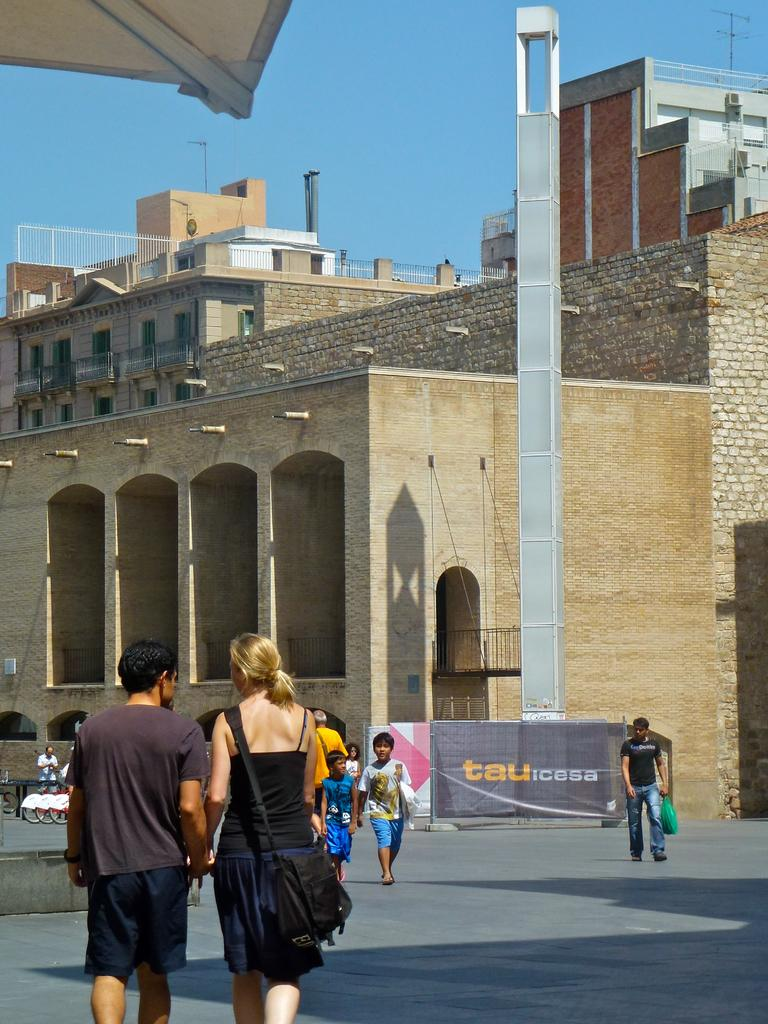What is located in the center of the image? There are buildings in the center of the image. What can be seen at the bottom of the image? There are people walking at the bottom of the image. What object is visible in the image that might have information or advertisements? There is a board visible in the image. What vertical structure can be seen in the image? There is a pole in the image. What is visible at the top of the image? The sky is visible at the top of the image. Can you tell me how many bananas are hanging from the pole in the image? There are no bananas present in the image; the pole is not associated with any fruit. Where is your aunt located in the image? There is no mention of an aunt in the image, so it is not possible to determine her location. 